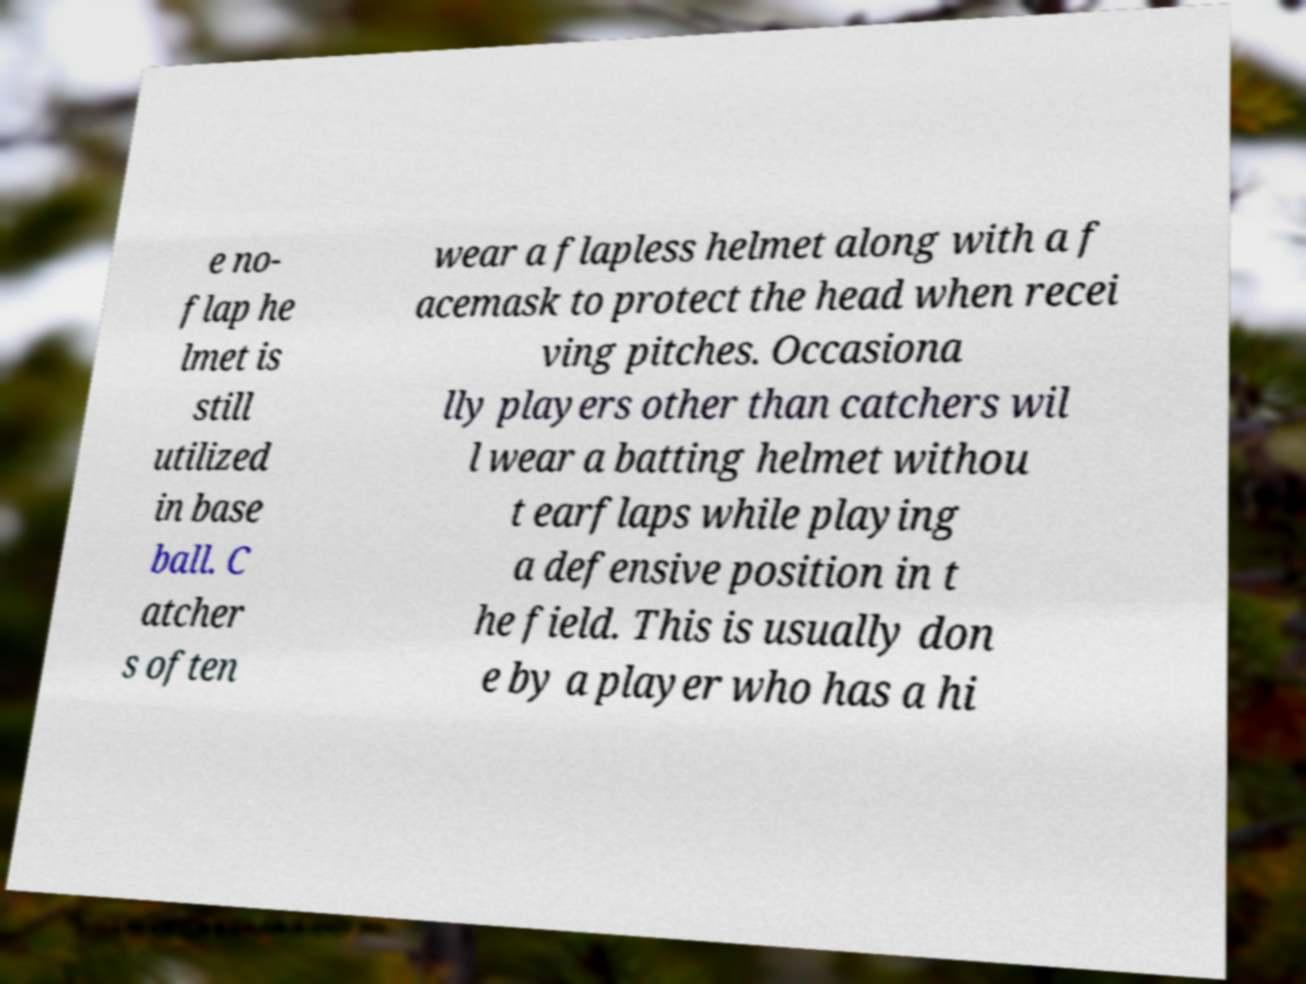Could you extract and type out the text from this image? e no- flap he lmet is still utilized in base ball. C atcher s often wear a flapless helmet along with a f acemask to protect the head when recei ving pitches. Occasiona lly players other than catchers wil l wear a batting helmet withou t earflaps while playing a defensive position in t he field. This is usually don e by a player who has a hi 